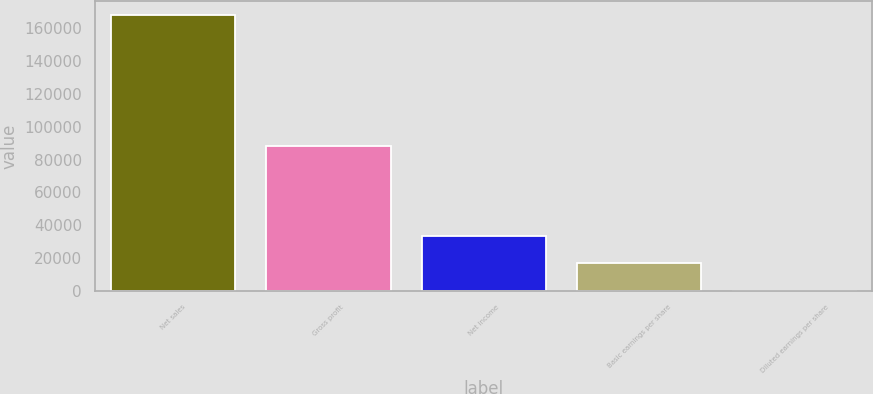Convert chart to OTSL. <chart><loc_0><loc_0><loc_500><loc_500><bar_chart><fcel>Net sales<fcel>Gross profit<fcel>Net income<fcel>Basic earnings per share<fcel>Diluted earnings per share<nl><fcel>168038<fcel>88074<fcel>33608<fcel>16804.2<fcel>0.5<nl></chart> 